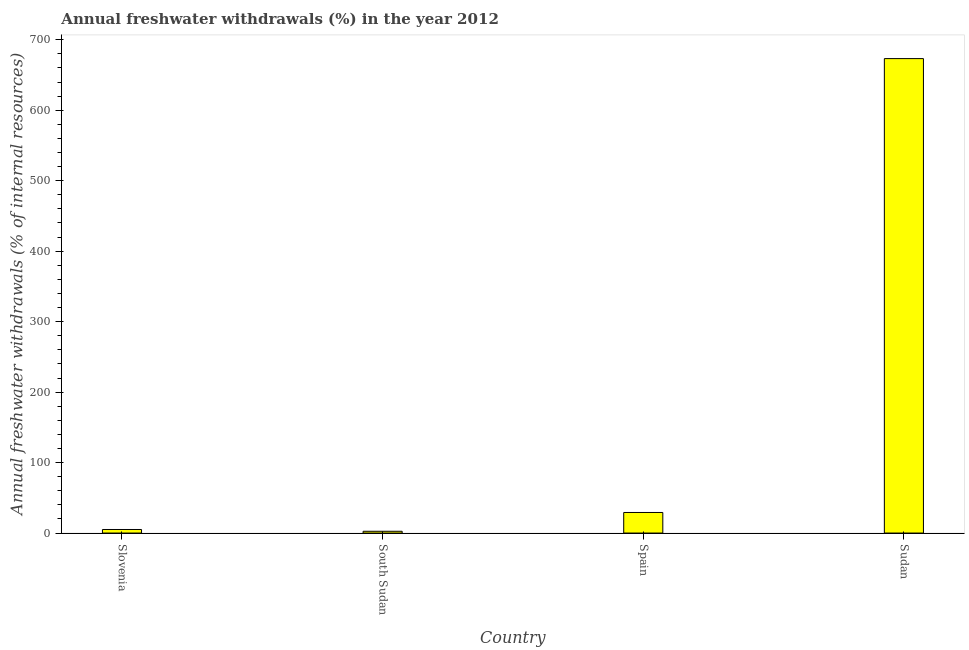Does the graph contain any zero values?
Keep it short and to the point. No. Does the graph contain grids?
Provide a succinct answer. No. What is the title of the graph?
Offer a very short reply. Annual freshwater withdrawals (%) in the year 2012. What is the label or title of the Y-axis?
Your answer should be compact. Annual freshwater withdrawals (% of internal resources). What is the annual freshwater withdrawals in Sudan?
Keep it short and to the point. 673.25. Across all countries, what is the maximum annual freshwater withdrawals?
Offer a terse response. 673.25. Across all countries, what is the minimum annual freshwater withdrawals?
Provide a succinct answer. 2.53. In which country was the annual freshwater withdrawals maximum?
Give a very brief answer. Sudan. In which country was the annual freshwater withdrawals minimum?
Your answer should be very brief. South Sudan. What is the sum of the annual freshwater withdrawals?
Offer a terse response. 710.02. What is the difference between the annual freshwater withdrawals in South Sudan and Sudan?
Give a very brief answer. -670.72. What is the average annual freshwater withdrawals per country?
Make the answer very short. 177.5. What is the median annual freshwater withdrawals?
Offer a terse response. 17.12. What is the ratio of the annual freshwater withdrawals in Spain to that in Sudan?
Your answer should be very brief. 0.04. Is the annual freshwater withdrawals in South Sudan less than that in Sudan?
Keep it short and to the point. Yes. Is the difference between the annual freshwater withdrawals in Spain and Sudan greater than the difference between any two countries?
Provide a succinct answer. No. What is the difference between the highest and the second highest annual freshwater withdrawals?
Your response must be concise. 644.06. Is the sum of the annual freshwater withdrawals in Slovenia and Sudan greater than the maximum annual freshwater withdrawals across all countries?
Offer a terse response. Yes. What is the difference between the highest and the lowest annual freshwater withdrawals?
Make the answer very short. 670.72. In how many countries, is the annual freshwater withdrawals greater than the average annual freshwater withdrawals taken over all countries?
Keep it short and to the point. 1. Are all the bars in the graph horizontal?
Give a very brief answer. No. How many countries are there in the graph?
Your response must be concise. 4. What is the Annual freshwater withdrawals (% of internal resources) in Slovenia?
Make the answer very short. 5.05. What is the Annual freshwater withdrawals (% of internal resources) in South Sudan?
Ensure brevity in your answer.  2.53. What is the Annual freshwater withdrawals (% of internal resources) in Spain?
Make the answer very short. 29.19. What is the Annual freshwater withdrawals (% of internal resources) of Sudan?
Provide a succinct answer. 673.25. What is the difference between the Annual freshwater withdrawals (% of internal resources) in Slovenia and South Sudan?
Keep it short and to the point. 2.51. What is the difference between the Annual freshwater withdrawals (% of internal resources) in Slovenia and Spain?
Ensure brevity in your answer.  -24.15. What is the difference between the Annual freshwater withdrawals (% of internal resources) in Slovenia and Sudan?
Offer a terse response. -668.2. What is the difference between the Annual freshwater withdrawals (% of internal resources) in South Sudan and Spain?
Keep it short and to the point. -26.66. What is the difference between the Annual freshwater withdrawals (% of internal resources) in South Sudan and Sudan?
Your answer should be very brief. -670.72. What is the difference between the Annual freshwater withdrawals (% of internal resources) in Spain and Sudan?
Keep it short and to the point. -644.06. What is the ratio of the Annual freshwater withdrawals (% of internal resources) in Slovenia to that in South Sudan?
Provide a succinct answer. 1.99. What is the ratio of the Annual freshwater withdrawals (% of internal resources) in Slovenia to that in Spain?
Make the answer very short. 0.17. What is the ratio of the Annual freshwater withdrawals (% of internal resources) in Slovenia to that in Sudan?
Ensure brevity in your answer.  0.01. What is the ratio of the Annual freshwater withdrawals (% of internal resources) in South Sudan to that in Spain?
Provide a short and direct response. 0.09. What is the ratio of the Annual freshwater withdrawals (% of internal resources) in South Sudan to that in Sudan?
Make the answer very short. 0. What is the ratio of the Annual freshwater withdrawals (% of internal resources) in Spain to that in Sudan?
Make the answer very short. 0.04. 